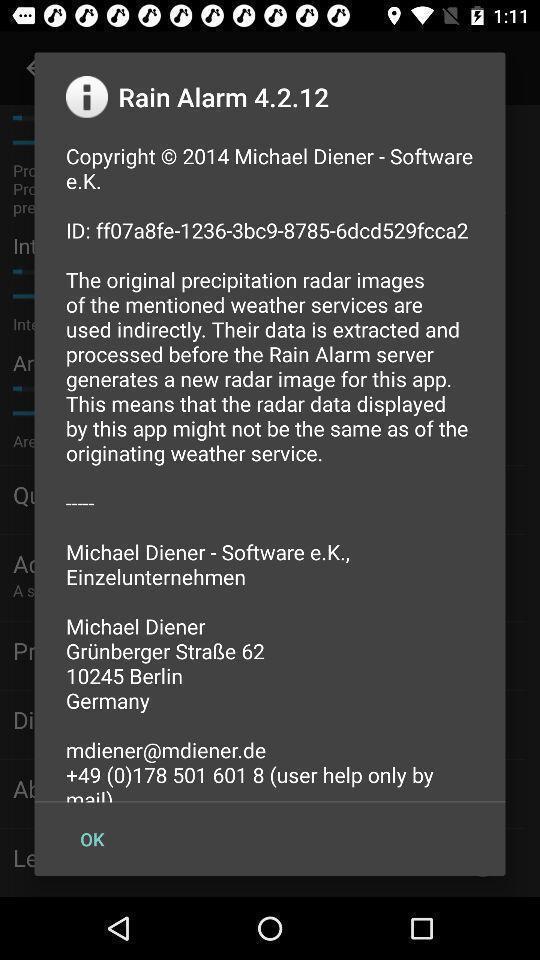Describe this image in words. Screen displaying the popup of alarm notification. 